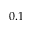Convert formula to latex. <formula><loc_0><loc_0><loc_500><loc_500>0 . 1</formula> 